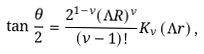<formula> <loc_0><loc_0><loc_500><loc_500>\tan \frac { \theta } { 2 } = \frac { 2 ^ { 1 - \nu } ( \Lambda R ) ^ { \nu } } { ( \nu - 1 ) ! } K _ { \nu } \left ( \Lambda r \right ) ,</formula> 